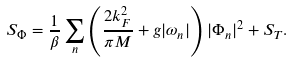Convert formula to latex. <formula><loc_0><loc_0><loc_500><loc_500>S _ { \Phi } = \frac { 1 } { \beta } \sum _ { n } \left ( \frac { 2 k _ { F } ^ { 2 } } { \pi M } + g | \omega _ { n } | \right ) | \Phi _ { n } | ^ { 2 } + S _ { T } .</formula> 